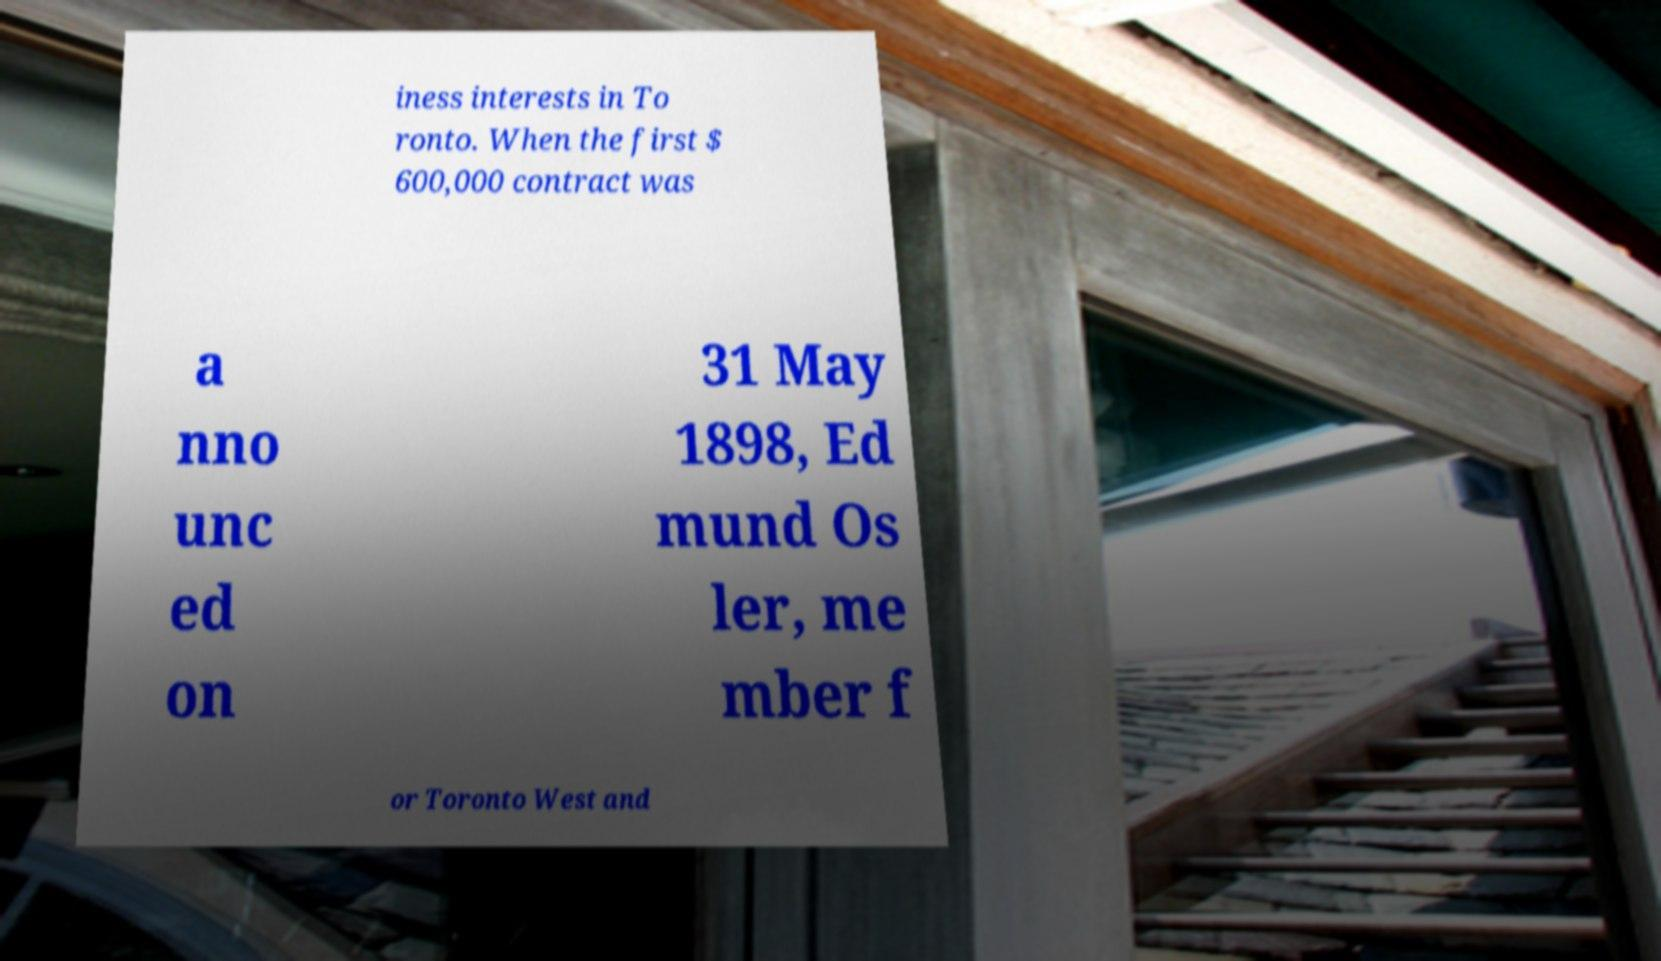Can you read and provide the text displayed in the image?This photo seems to have some interesting text. Can you extract and type it out for me? iness interests in To ronto. When the first $ 600,000 contract was a nno unc ed on 31 May 1898, Ed mund Os ler, me mber f or Toronto West and 